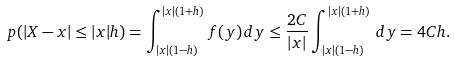Convert formula to latex. <formula><loc_0><loc_0><loc_500><loc_500>\ p ( | X - x | \leq | x | h ) = \int _ { | x | ( 1 - h ) } ^ { | x | ( 1 + h ) } f ( y ) \, d y \leq \frac { 2 C } { | x | } \int _ { | x | ( 1 - h ) } ^ { | x | ( 1 + h ) } \, d y = 4 C h .</formula> 